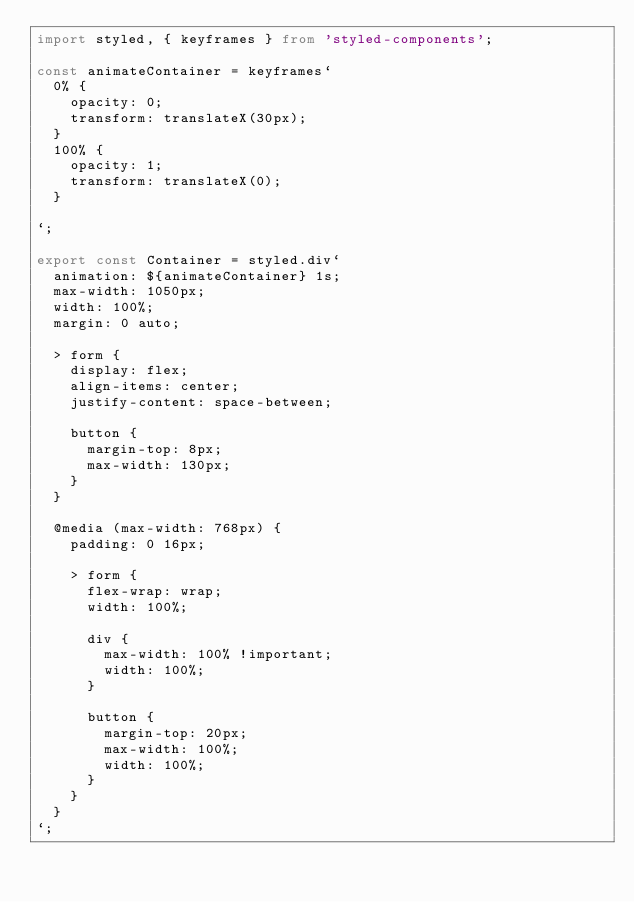<code> <loc_0><loc_0><loc_500><loc_500><_TypeScript_>import styled, { keyframes } from 'styled-components';

const animateContainer = keyframes`
  0% {
    opacity: 0;
    transform: translateX(30px);
  }
  100% {
    opacity: 1;
    transform: translateX(0);
  }

`;

export const Container = styled.div`
  animation: ${animateContainer} 1s;
  max-width: 1050px;
  width: 100%;
  margin: 0 auto;

  > form {
    display: flex;
    align-items: center;
    justify-content: space-between;

    button {
      margin-top: 8px;
      max-width: 130px;
    }
  }

  @media (max-width: 768px) {
    padding: 0 16px;

    > form {
      flex-wrap: wrap;
      width: 100%;

      div {
        max-width: 100% !important;
        width: 100%;
      }

      button {
        margin-top: 20px;
        max-width: 100%;
        width: 100%;
      }
    }
  }
`;
</code> 